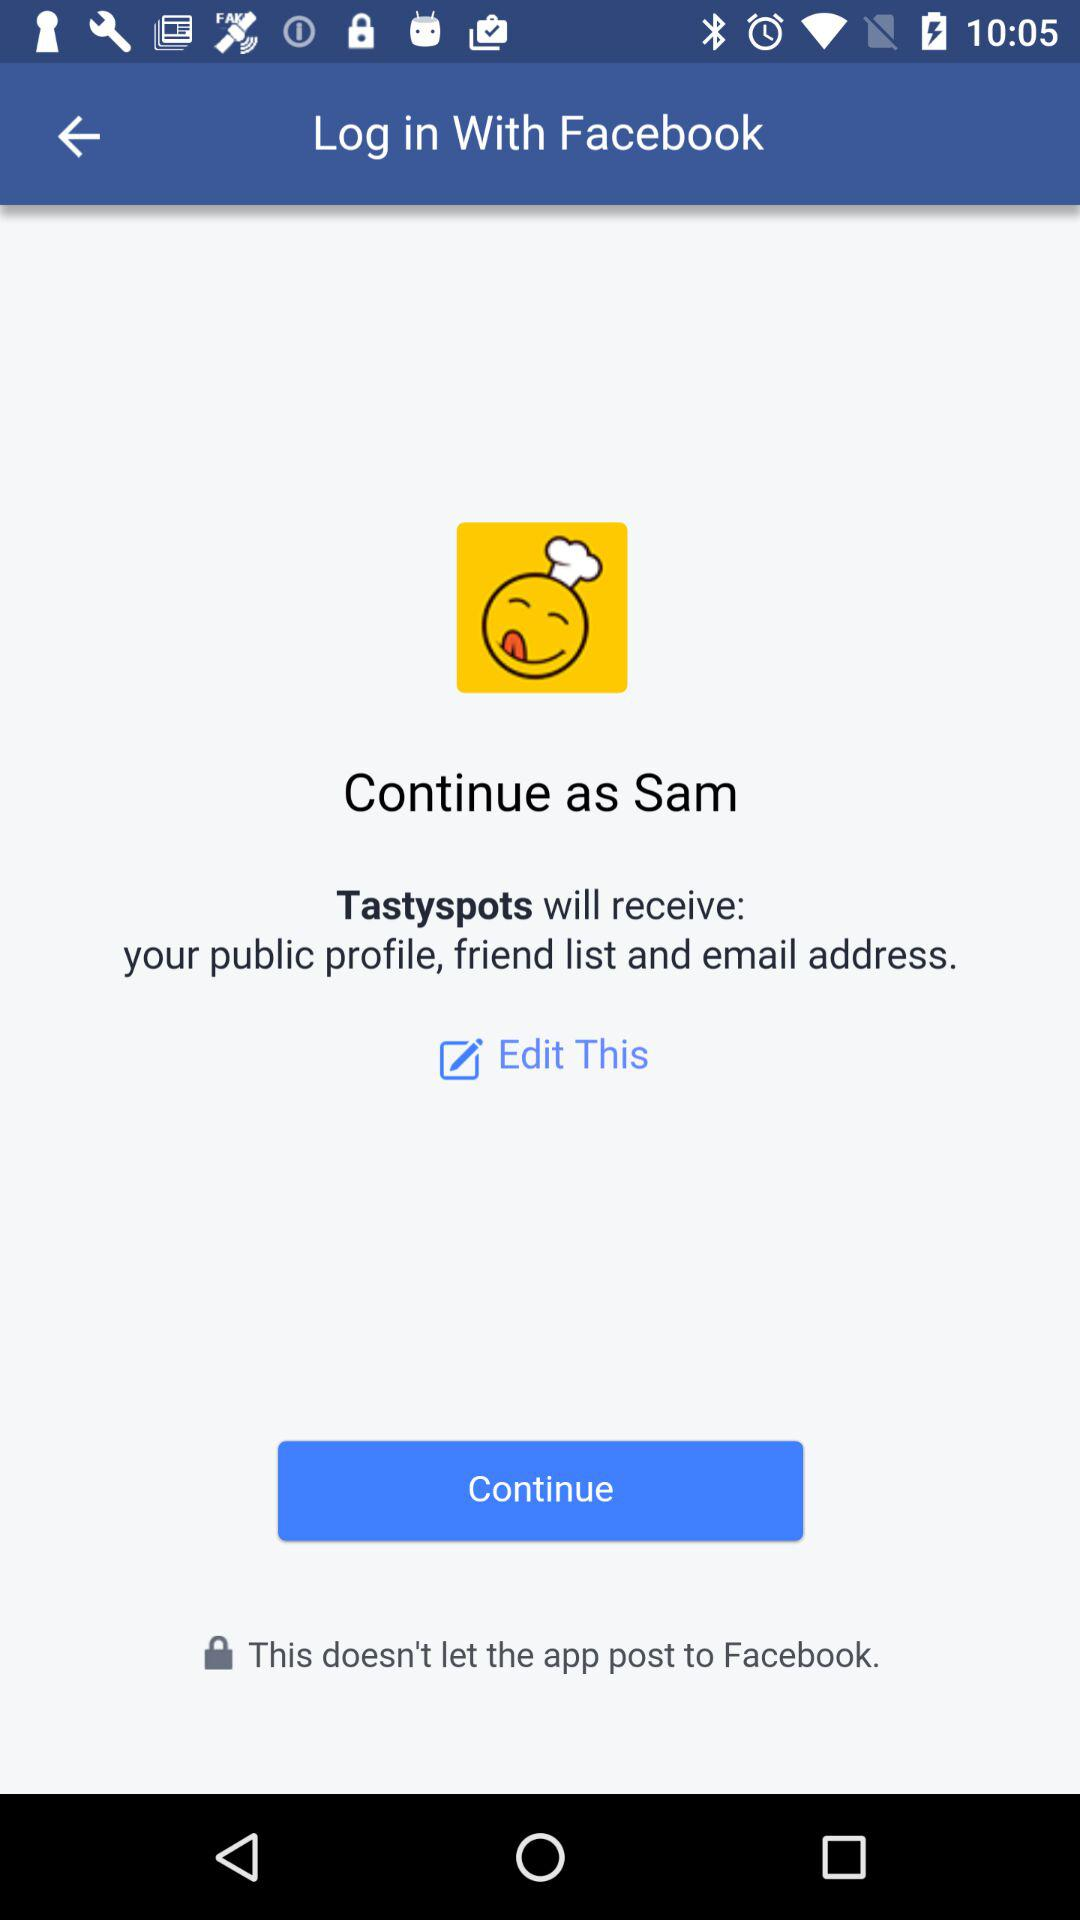What application is asking for permission? The application asking for permission is "Tastyspots". 